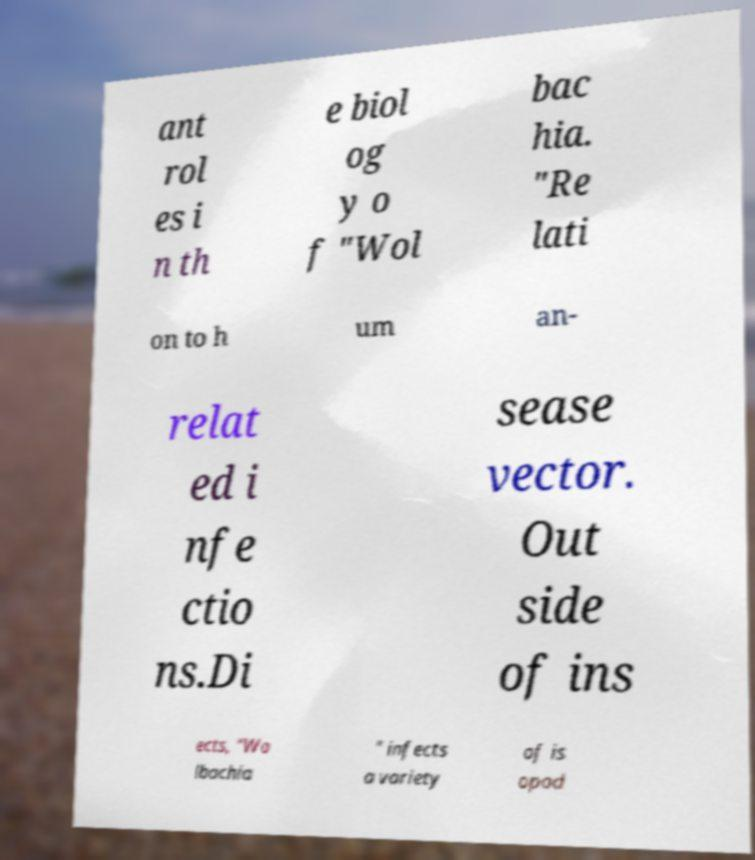I need the written content from this picture converted into text. Can you do that? ant rol es i n th e biol og y o f "Wol bac hia. "Re lati on to h um an- relat ed i nfe ctio ns.Di sease vector. Out side of ins ects, "Wo lbachia " infects a variety of is opod 